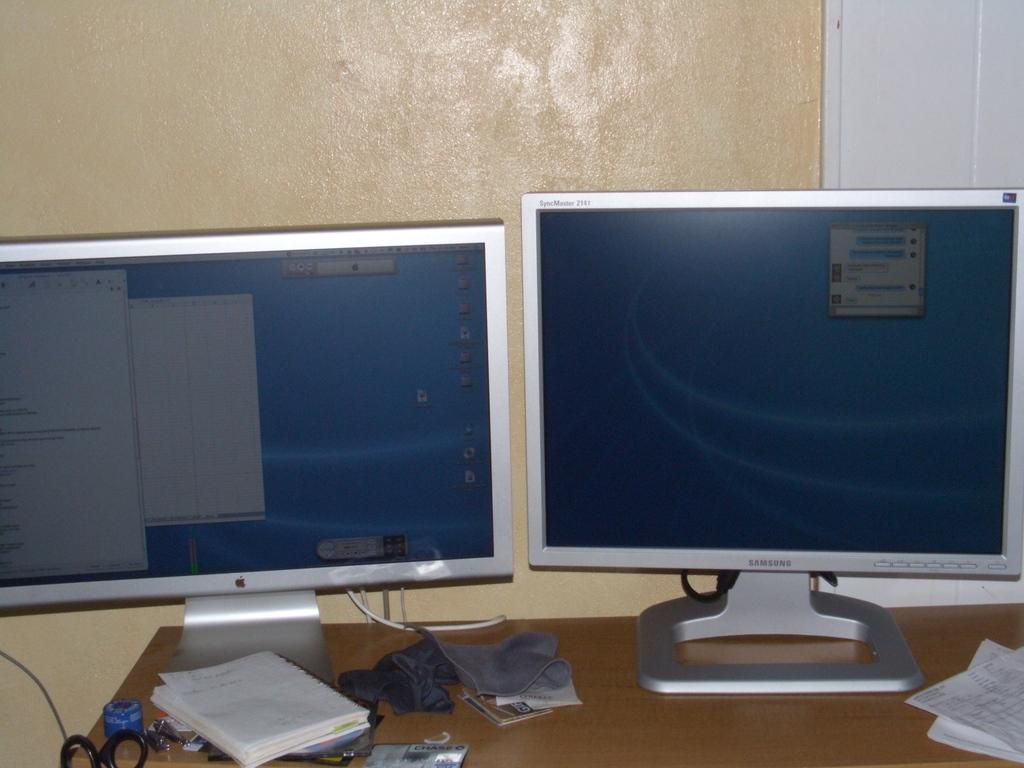<image>
Write a terse but informative summary of the picture. Two screens sit side by side on a desk, one is a Samsung. 